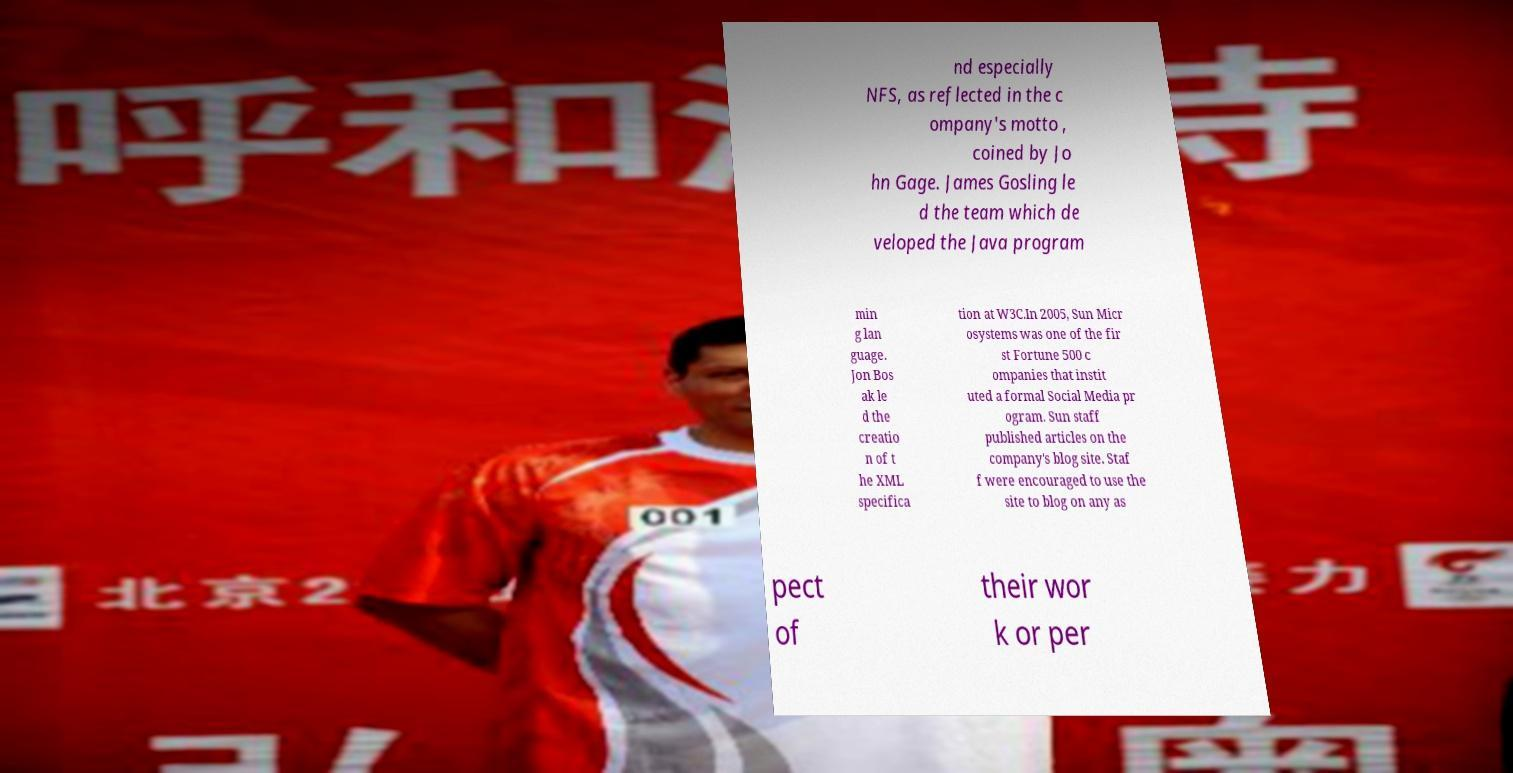I need the written content from this picture converted into text. Can you do that? nd especially NFS, as reflected in the c ompany's motto , coined by Jo hn Gage. James Gosling le d the team which de veloped the Java program min g lan guage. Jon Bos ak le d the creatio n of t he XML specifica tion at W3C.In 2005, Sun Micr osystems was one of the fir st Fortune 500 c ompanies that instit uted a formal Social Media pr ogram. Sun staff published articles on the company's blog site. Staf f were encouraged to use the site to blog on any as pect of their wor k or per 